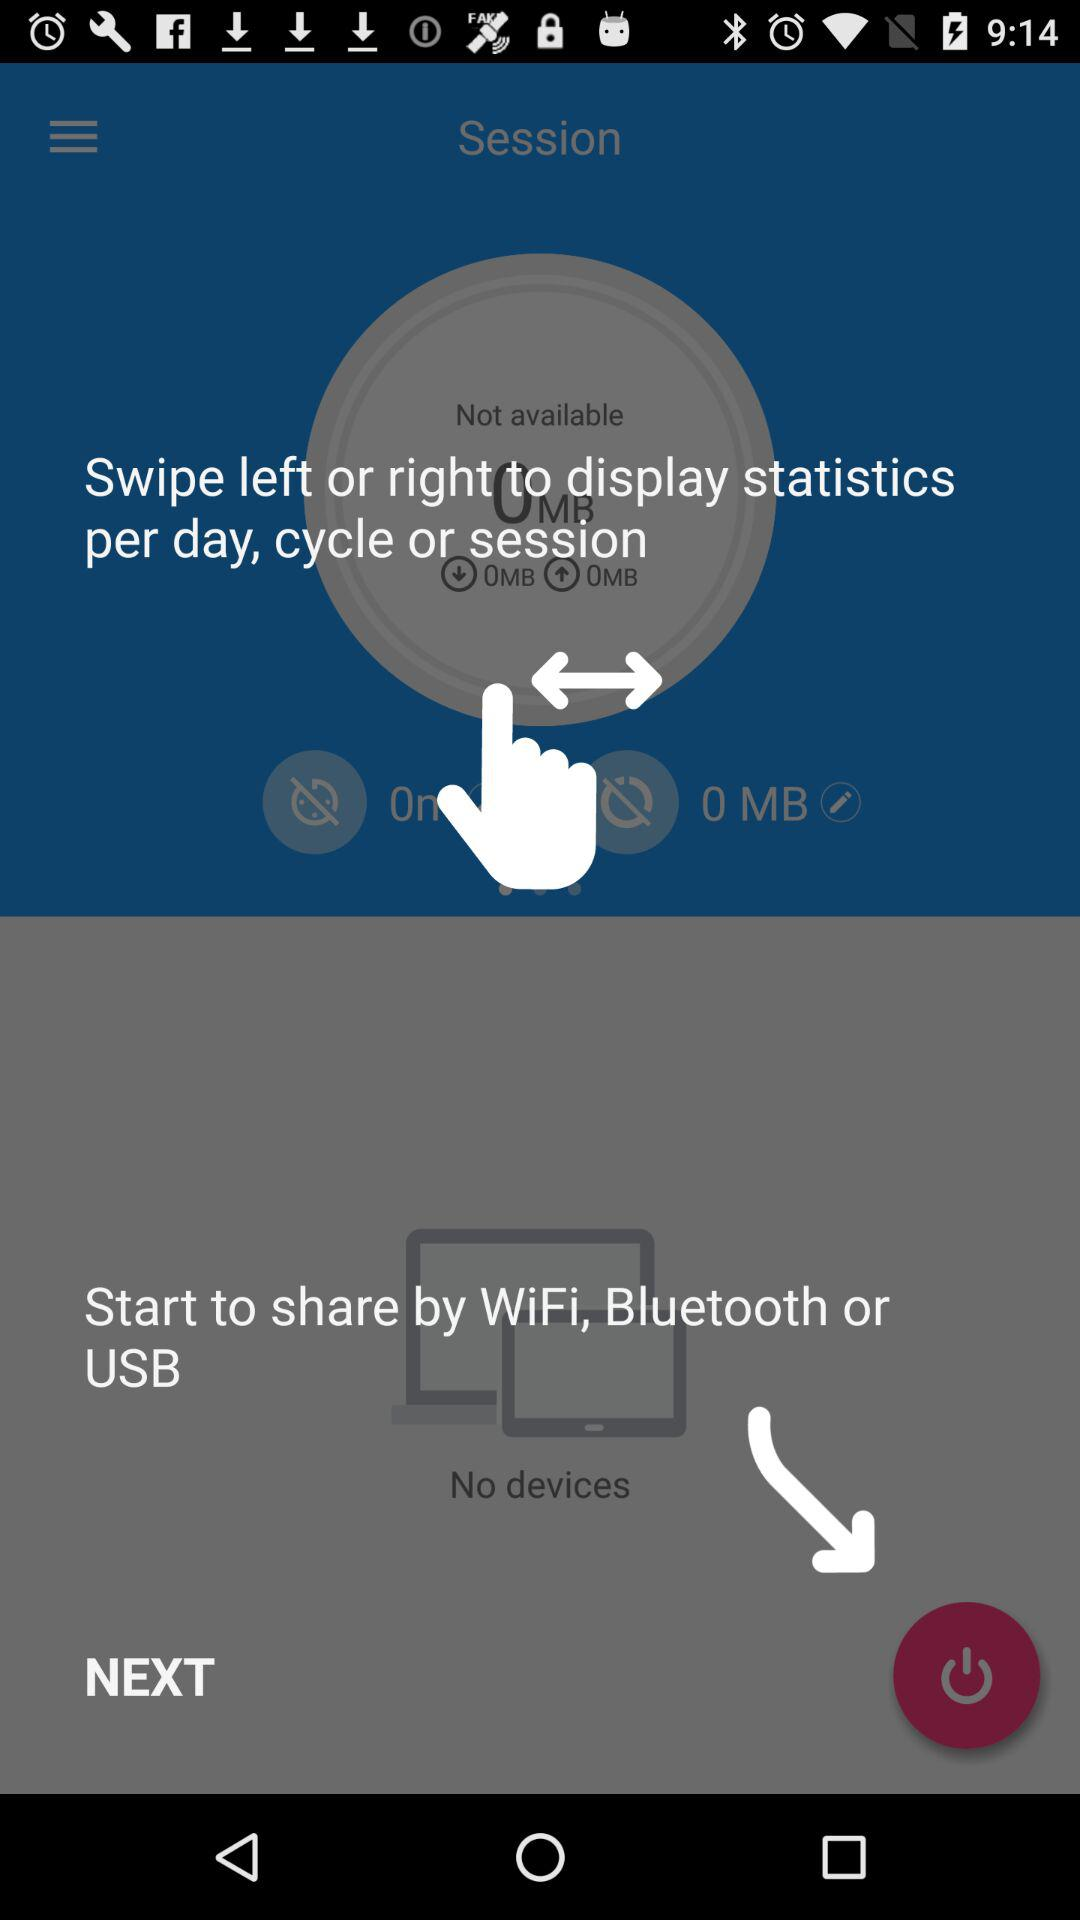How many devices are connected?
Answer the question using a single word or phrase. 0 